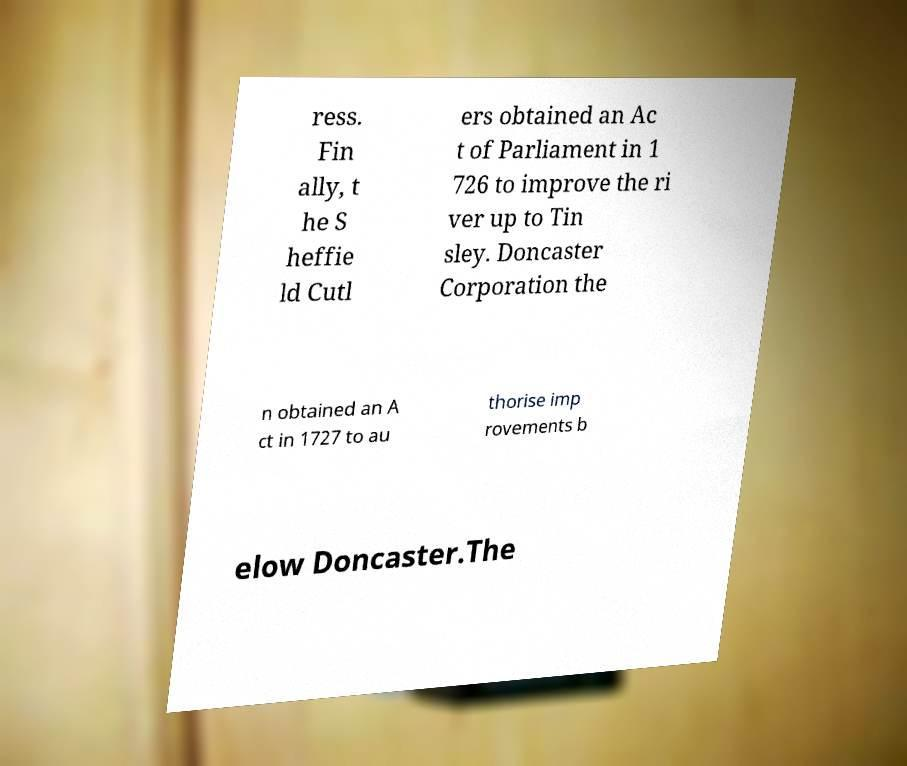Could you assist in decoding the text presented in this image and type it out clearly? ress. Fin ally, t he S heffie ld Cutl ers obtained an Ac t of Parliament in 1 726 to improve the ri ver up to Tin sley. Doncaster Corporation the n obtained an A ct in 1727 to au thorise imp rovements b elow Doncaster.The 